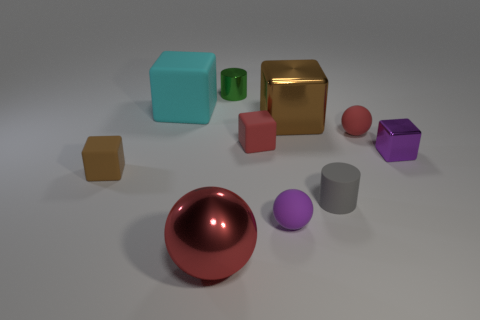Subtract all small red matte blocks. How many blocks are left? 4 Subtract all yellow cylinders. How many red spheres are left? 2 Subtract all purple balls. How many balls are left? 2 Subtract 1 blocks. How many blocks are left? 4 Subtract all gray blocks. Subtract all yellow cylinders. How many blocks are left? 5 Subtract all balls. How many objects are left? 7 Subtract 0 purple cylinders. How many objects are left? 10 Subtract all tiny cyan metal cylinders. Subtract all red balls. How many objects are left? 8 Add 6 rubber balls. How many rubber balls are left? 8 Add 5 small yellow metallic blocks. How many small yellow metallic blocks exist? 5 